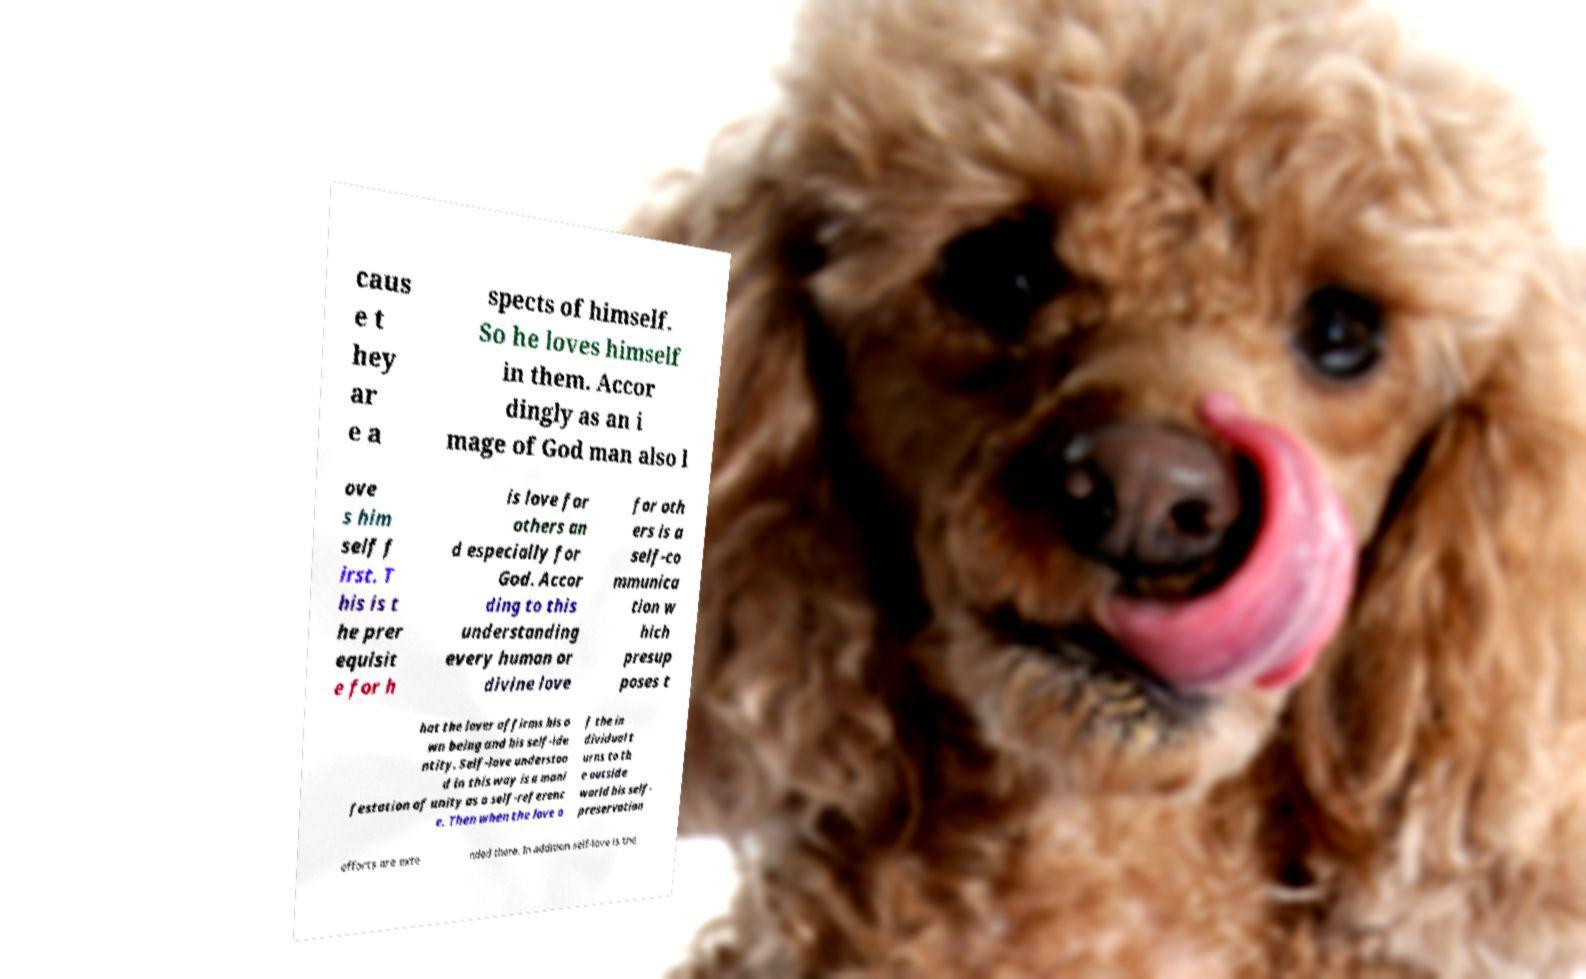For documentation purposes, I need the text within this image transcribed. Could you provide that? caus e t hey ar e a spects of himself. So he loves himself in them. Accor dingly as an i mage of God man also l ove s him self f irst. T his is t he prer equisit e for h is love for others an d especially for God. Accor ding to this understanding every human or divine love for oth ers is a self-co mmunica tion w hich presup poses t hat the lover affirms his o wn being and his self-ide ntity. Self-love understoo d in this way is a mani festation of unity as a self-referenc e. Then when the love o f the in dividual t urns to th e outside world his self- preservation efforts are exte nded there. In addition self-love is the 